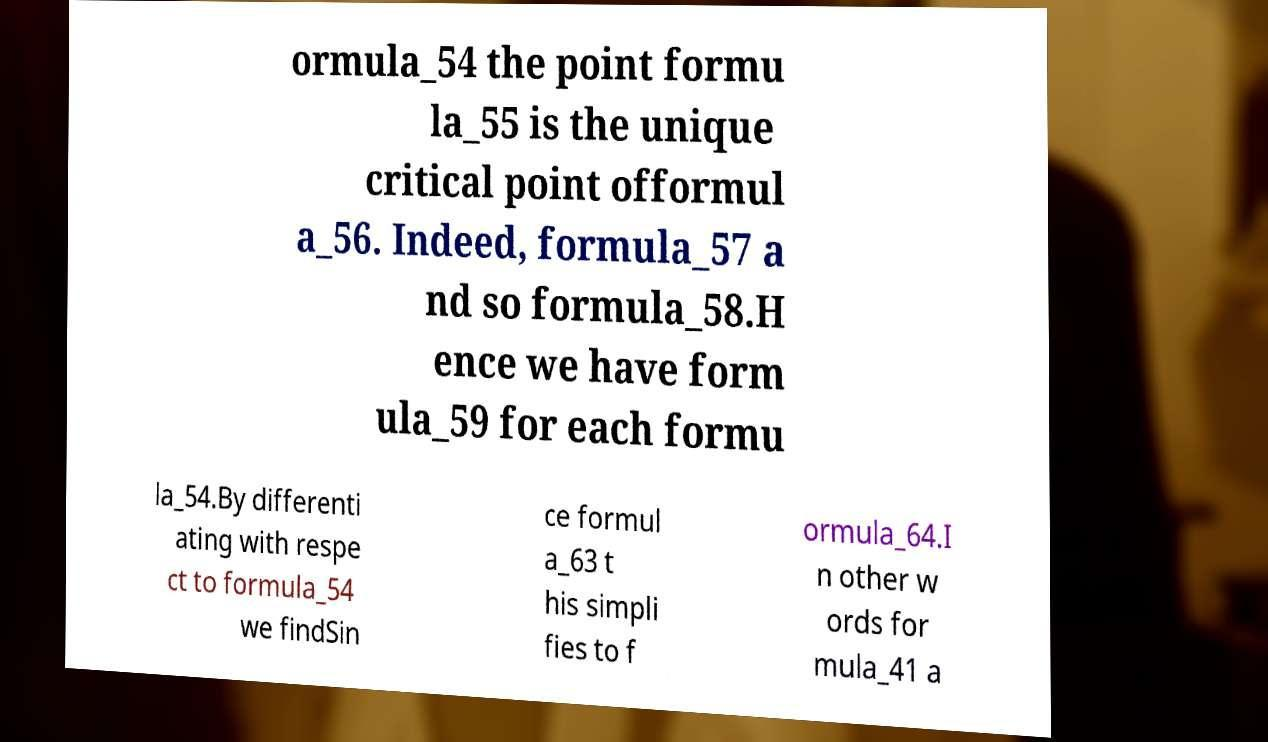There's text embedded in this image that I need extracted. Can you transcribe it verbatim? ormula_54 the point formu la_55 is the unique critical point offormul a_56. Indeed, formula_57 a nd so formula_58.H ence we have form ula_59 for each formu la_54.By differenti ating with respe ct to formula_54 we findSin ce formul a_63 t his simpli fies to f ormula_64.I n other w ords for mula_41 a 